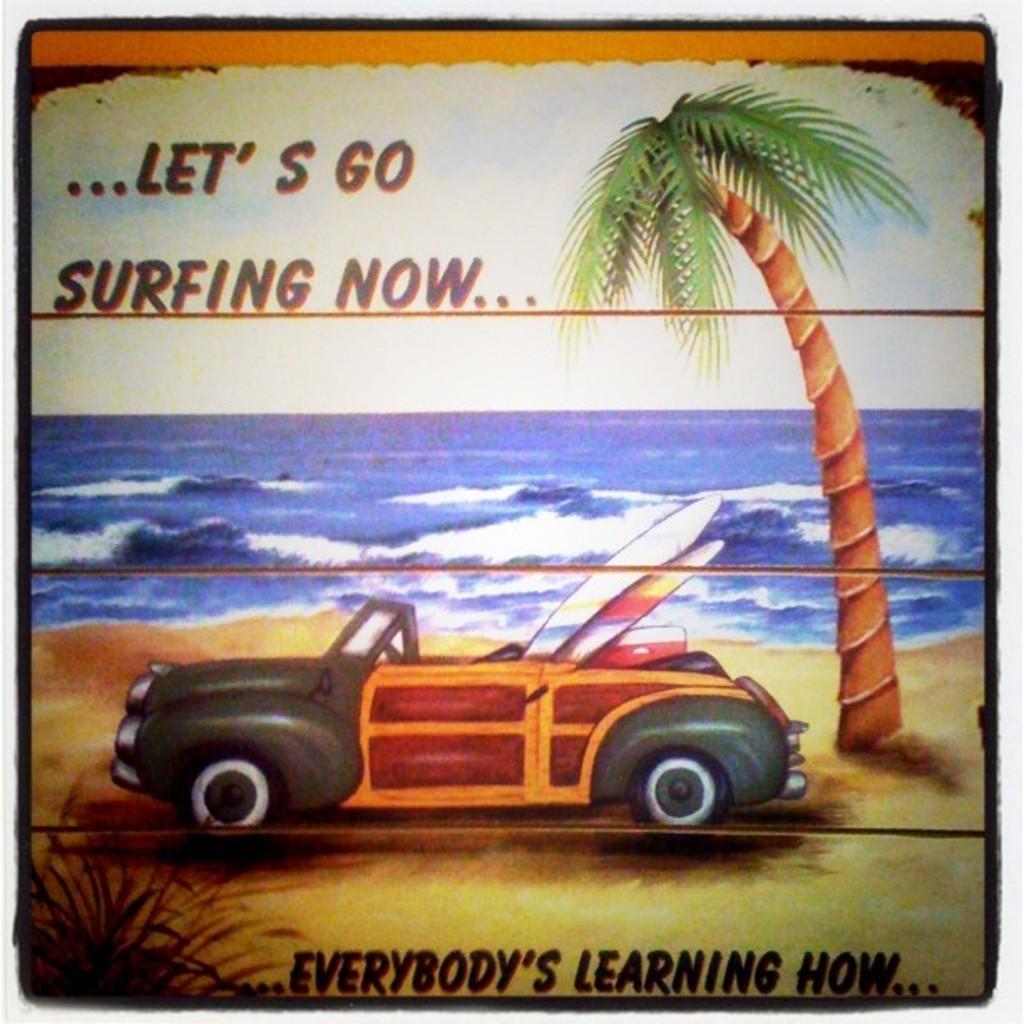Describe this image in one or two sentences. This is an edited image in which there is some text, there are leaves and there is a tree, there is an ocean and there is a car. 